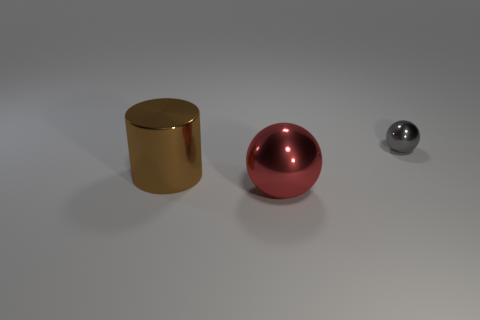What materials do the objects in the image seem to be made of? The objects in the image appear to be made of different metals. The cylinder on the left has a golden metallic sheen, suggesting it could be made of a material similar to brass or gold. The larger sphere in the center has a reddish hue with a reflective surface, resembling polished copper. Meanwhile, the smaller sphere to the right has a silver color indicative of steel or aluminum. 